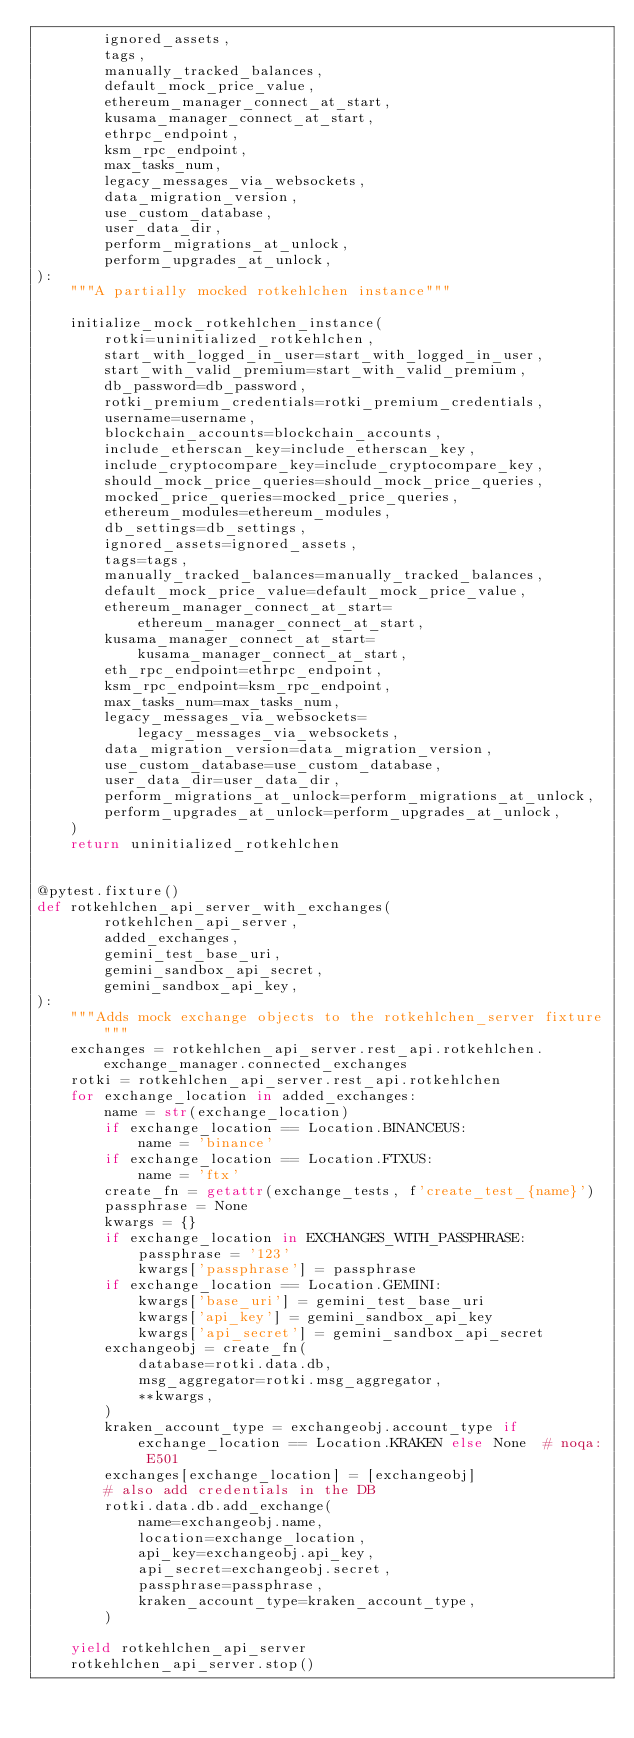Convert code to text. <code><loc_0><loc_0><loc_500><loc_500><_Python_>        ignored_assets,
        tags,
        manually_tracked_balances,
        default_mock_price_value,
        ethereum_manager_connect_at_start,
        kusama_manager_connect_at_start,
        ethrpc_endpoint,
        ksm_rpc_endpoint,
        max_tasks_num,
        legacy_messages_via_websockets,
        data_migration_version,
        use_custom_database,
        user_data_dir,
        perform_migrations_at_unlock,
        perform_upgrades_at_unlock,
):
    """A partially mocked rotkehlchen instance"""

    initialize_mock_rotkehlchen_instance(
        rotki=uninitialized_rotkehlchen,
        start_with_logged_in_user=start_with_logged_in_user,
        start_with_valid_premium=start_with_valid_premium,
        db_password=db_password,
        rotki_premium_credentials=rotki_premium_credentials,
        username=username,
        blockchain_accounts=blockchain_accounts,
        include_etherscan_key=include_etherscan_key,
        include_cryptocompare_key=include_cryptocompare_key,
        should_mock_price_queries=should_mock_price_queries,
        mocked_price_queries=mocked_price_queries,
        ethereum_modules=ethereum_modules,
        db_settings=db_settings,
        ignored_assets=ignored_assets,
        tags=tags,
        manually_tracked_balances=manually_tracked_balances,
        default_mock_price_value=default_mock_price_value,
        ethereum_manager_connect_at_start=ethereum_manager_connect_at_start,
        kusama_manager_connect_at_start=kusama_manager_connect_at_start,
        eth_rpc_endpoint=ethrpc_endpoint,
        ksm_rpc_endpoint=ksm_rpc_endpoint,
        max_tasks_num=max_tasks_num,
        legacy_messages_via_websockets=legacy_messages_via_websockets,
        data_migration_version=data_migration_version,
        use_custom_database=use_custom_database,
        user_data_dir=user_data_dir,
        perform_migrations_at_unlock=perform_migrations_at_unlock,
        perform_upgrades_at_unlock=perform_upgrades_at_unlock,
    )
    return uninitialized_rotkehlchen


@pytest.fixture()
def rotkehlchen_api_server_with_exchanges(
        rotkehlchen_api_server,
        added_exchanges,
        gemini_test_base_uri,
        gemini_sandbox_api_secret,
        gemini_sandbox_api_key,
):
    """Adds mock exchange objects to the rotkehlchen_server fixture"""
    exchanges = rotkehlchen_api_server.rest_api.rotkehlchen.exchange_manager.connected_exchanges
    rotki = rotkehlchen_api_server.rest_api.rotkehlchen
    for exchange_location in added_exchanges:
        name = str(exchange_location)
        if exchange_location == Location.BINANCEUS:
            name = 'binance'
        if exchange_location == Location.FTXUS:
            name = 'ftx'
        create_fn = getattr(exchange_tests, f'create_test_{name}')
        passphrase = None
        kwargs = {}
        if exchange_location in EXCHANGES_WITH_PASSPHRASE:
            passphrase = '123'
            kwargs['passphrase'] = passphrase
        if exchange_location == Location.GEMINI:
            kwargs['base_uri'] = gemini_test_base_uri
            kwargs['api_key'] = gemini_sandbox_api_key
            kwargs['api_secret'] = gemini_sandbox_api_secret
        exchangeobj = create_fn(
            database=rotki.data.db,
            msg_aggregator=rotki.msg_aggregator,
            **kwargs,
        )
        kraken_account_type = exchangeobj.account_type if exchange_location == Location.KRAKEN else None  # noqa: E501
        exchanges[exchange_location] = [exchangeobj]
        # also add credentials in the DB
        rotki.data.db.add_exchange(
            name=exchangeobj.name,
            location=exchange_location,
            api_key=exchangeobj.api_key,
            api_secret=exchangeobj.secret,
            passphrase=passphrase,
            kraken_account_type=kraken_account_type,
        )

    yield rotkehlchen_api_server
    rotkehlchen_api_server.stop()
</code> 